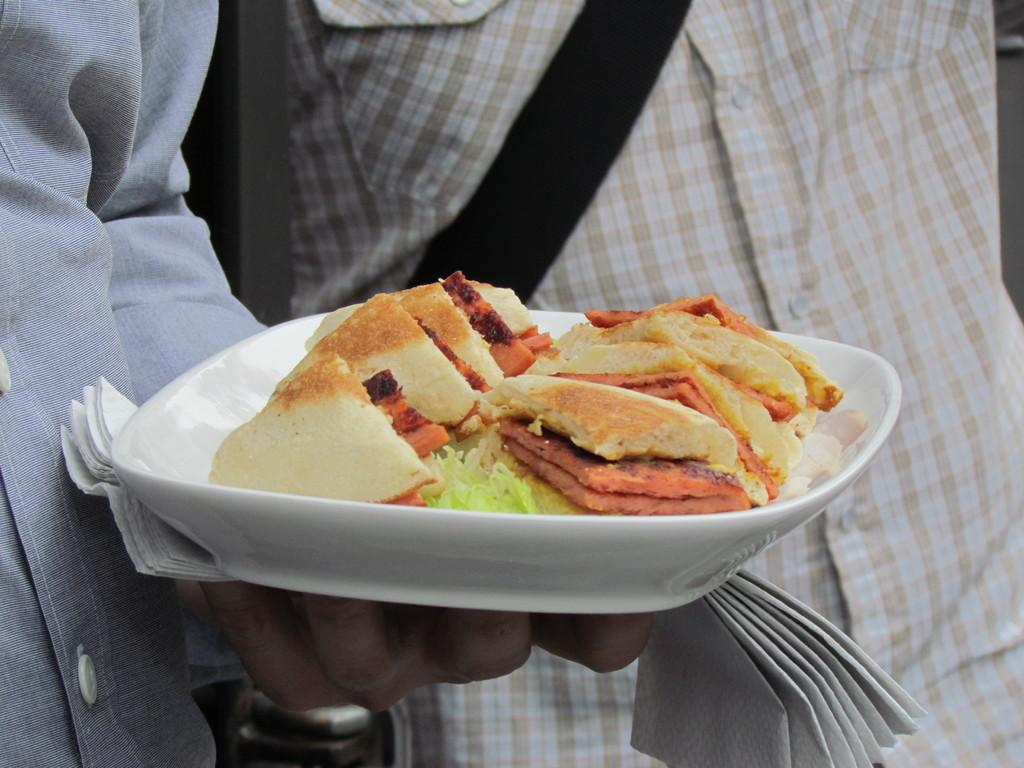What is the person in the image holding? The person is holding a plate with food on it. What else is the person holding besides the plate? The person is also holding tissues. Can you describe the person in the background of the image? There is a person with a cream and white check shirt in the background of the image. What type of force is being applied to the drum in the image? There is no drum present in the image. What ornament is hanging from the ceiling in the image? There is no ornament hanging from the ceiling in the image. 